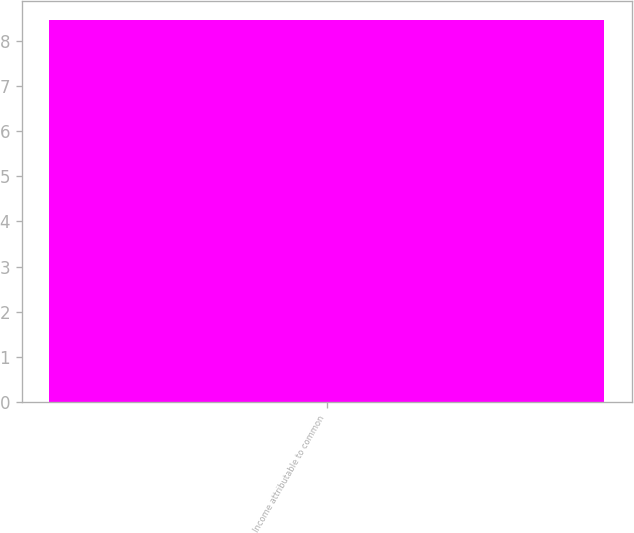<chart> <loc_0><loc_0><loc_500><loc_500><bar_chart><fcel>Income attributable to common<nl><fcel>8.46<nl></chart> 